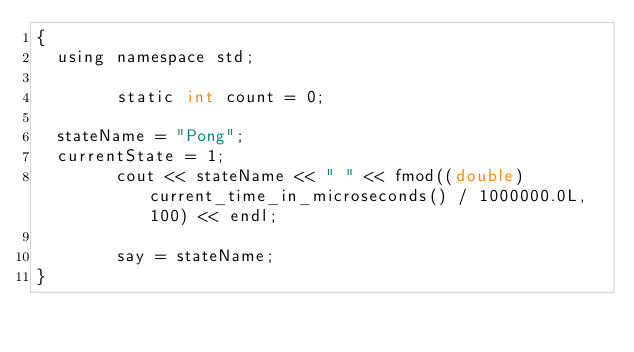<code> <loc_0><loc_0><loc_500><loc_500><_ObjectiveC_>{
  using namespace std;
        
        static int count = 0;
        
  stateName = "Pong";
  currentState = 1;
        cout << stateName << " " << fmod((double)current_time_in_microseconds() / 1000000.0L, 100) << endl;

        say = stateName;
}
</code> 